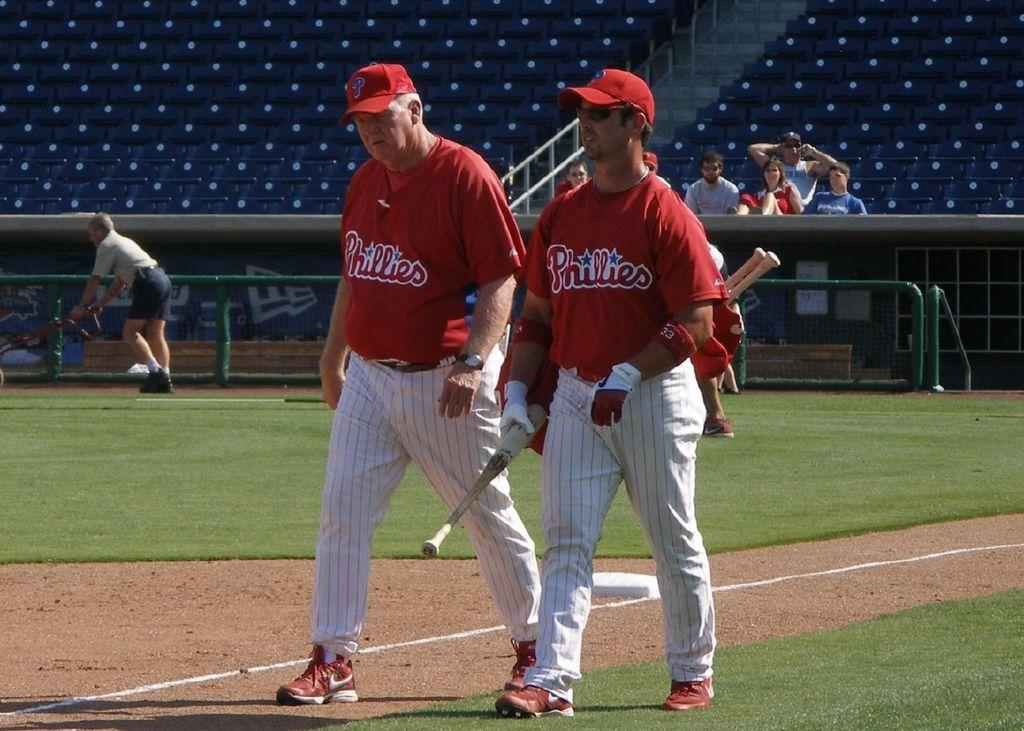<image>
Relay a brief, clear account of the picture shown. The baseball player holding the bats is wearing a red Phillies jersey 